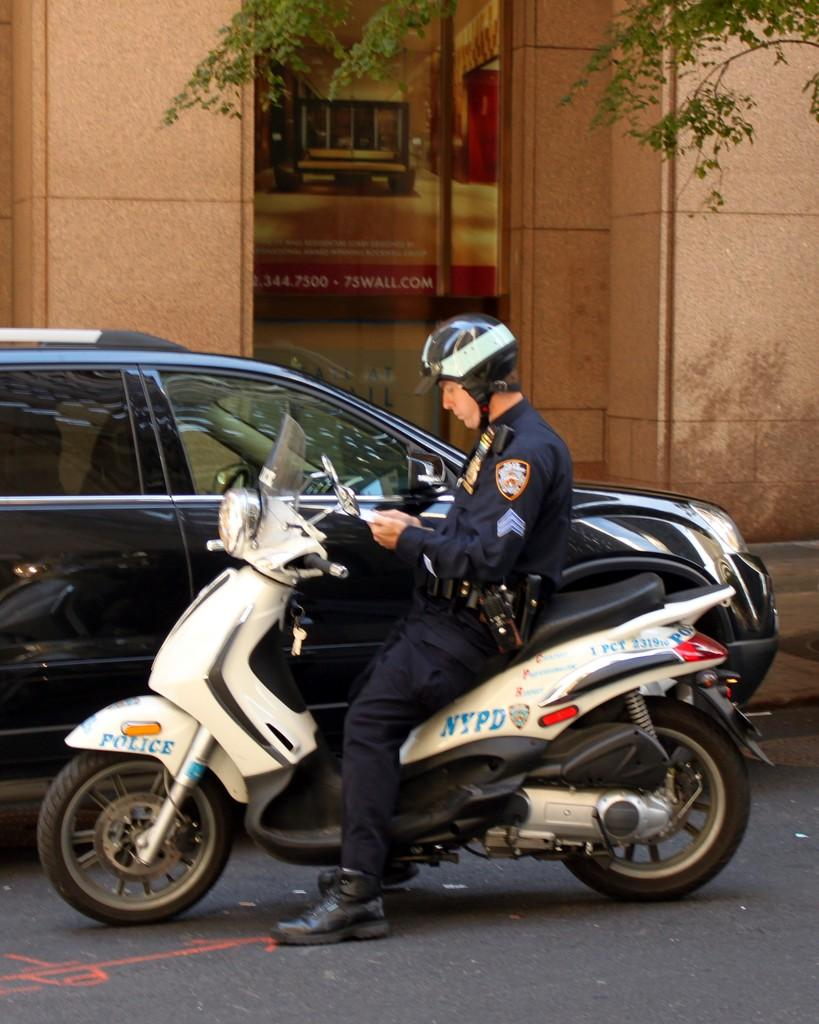What is the main subject of the image? The main subject of the image is a man. What is the man wearing in the image? The man is wearing clothes, shoes, and a helmet in the image. What is the man sitting on in the image? The man is sitting on a two-wheeler in the image. What else can be seen in the image besides the man? There is a car on the road, a building, and leaves visible in the image. What type of bean is growing in the plantation shown in the image? There is no plantation or bean present in the image; it features a man sitting on a two-wheeler with a car, building, and leaves visible in the background. 